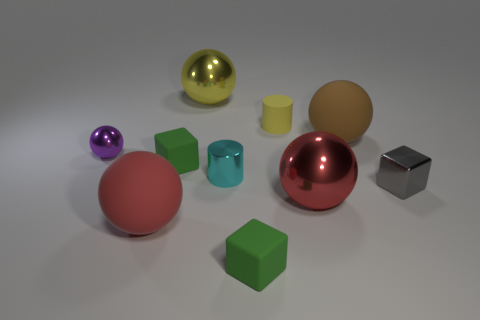Subtract all tiny matte blocks. How many blocks are left? 1 Subtract all yellow cylinders. How many cylinders are left? 1 Subtract all cylinders. How many objects are left? 8 Subtract 1 balls. How many balls are left? 4 Subtract 1 gray cubes. How many objects are left? 9 Subtract all yellow cylinders. Subtract all green blocks. How many cylinders are left? 1 Subtract all cyan cylinders. How many green blocks are left? 2 Subtract all blue shiny things. Subtract all big red objects. How many objects are left? 8 Add 9 large brown balls. How many large brown balls are left? 10 Add 8 large red matte spheres. How many large red matte spheres exist? 9 